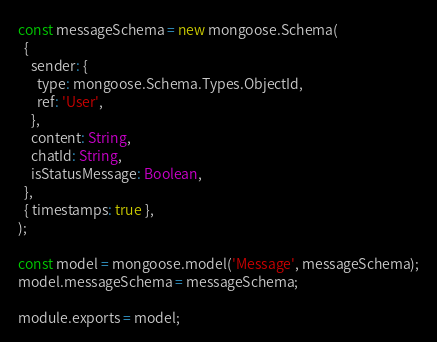Convert code to text. <code><loc_0><loc_0><loc_500><loc_500><_JavaScript_>const messageSchema = new mongoose.Schema(
  {
    sender: {
      type: mongoose.Schema.Types.ObjectId,
      ref: 'User',
    },
    content: String,
    chatId: String,
    isStatusMessage: Boolean,
  },
  { timestamps: true },
);

const model = mongoose.model('Message', messageSchema);
model.messageSchema = messageSchema;

module.exports = model;
</code> 